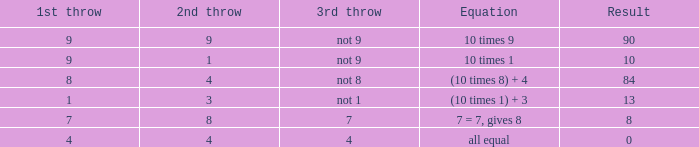If the formula is completely balanced, what is the third toss? 4.0. 